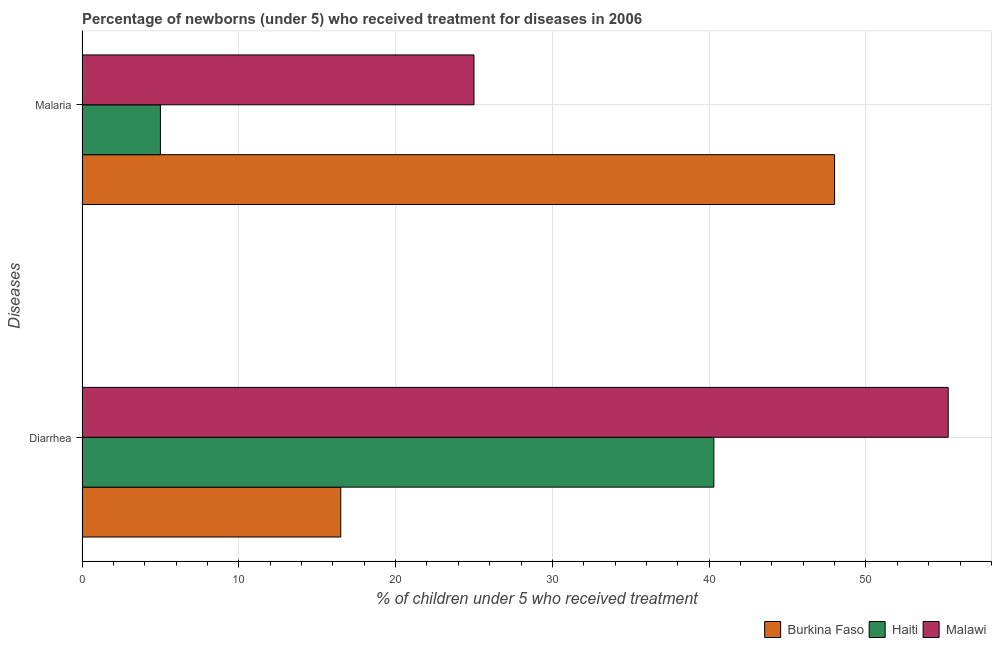How many different coloured bars are there?
Offer a very short reply. 3. How many groups of bars are there?
Your answer should be very brief. 2. Are the number of bars per tick equal to the number of legend labels?
Your answer should be very brief. Yes. Are the number of bars on each tick of the Y-axis equal?
Provide a short and direct response. Yes. How many bars are there on the 1st tick from the top?
Offer a very short reply. 3. How many bars are there on the 2nd tick from the bottom?
Provide a succinct answer. 3. What is the label of the 1st group of bars from the top?
Make the answer very short. Malaria. What is the percentage of children who received treatment for diarrhoea in Burkina Faso?
Make the answer very short. 16.5. Across all countries, what is the maximum percentage of children who received treatment for malaria?
Give a very brief answer. 48. Across all countries, what is the minimum percentage of children who received treatment for diarrhoea?
Your response must be concise. 16.5. In which country was the percentage of children who received treatment for malaria maximum?
Provide a short and direct response. Burkina Faso. In which country was the percentage of children who received treatment for malaria minimum?
Ensure brevity in your answer.  Haiti. What is the total percentage of children who received treatment for diarrhoea in the graph?
Your answer should be very brief. 112.05. What is the difference between the percentage of children who received treatment for diarrhoea in Haiti and the percentage of children who received treatment for malaria in Malawi?
Ensure brevity in your answer.  15.3. What is the average percentage of children who received treatment for diarrhoea per country?
Keep it short and to the point. 37.35. What is the difference between the percentage of children who received treatment for diarrhoea and percentage of children who received treatment for malaria in Malawi?
Keep it short and to the point. 30.25. What does the 1st bar from the top in Diarrhea represents?
Ensure brevity in your answer.  Malawi. What does the 3rd bar from the bottom in Diarrhea represents?
Keep it short and to the point. Malawi. What is the difference between two consecutive major ticks on the X-axis?
Your response must be concise. 10. Are the values on the major ticks of X-axis written in scientific E-notation?
Your response must be concise. No. Does the graph contain any zero values?
Your answer should be compact. No. Does the graph contain grids?
Keep it short and to the point. Yes. Where does the legend appear in the graph?
Give a very brief answer. Bottom right. How many legend labels are there?
Your response must be concise. 3. How are the legend labels stacked?
Make the answer very short. Horizontal. What is the title of the graph?
Keep it short and to the point. Percentage of newborns (under 5) who received treatment for diseases in 2006. Does "Grenada" appear as one of the legend labels in the graph?
Provide a succinct answer. No. What is the label or title of the X-axis?
Provide a succinct answer. % of children under 5 who received treatment. What is the label or title of the Y-axis?
Make the answer very short. Diseases. What is the % of children under 5 who received treatment of Burkina Faso in Diarrhea?
Provide a short and direct response. 16.5. What is the % of children under 5 who received treatment of Haiti in Diarrhea?
Make the answer very short. 40.3. What is the % of children under 5 who received treatment of Malawi in Diarrhea?
Provide a succinct answer. 55.25. What is the % of children under 5 who received treatment in Malawi in Malaria?
Keep it short and to the point. 25. Across all Diseases, what is the maximum % of children under 5 who received treatment of Haiti?
Offer a terse response. 40.3. Across all Diseases, what is the maximum % of children under 5 who received treatment in Malawi?
Give a very brief answer. 55.25. Across all Diseases, what is the minimum % of children under 5 who received treatment of Burkina Faso?
Your response must be concise. 16.5. What is the total % of children under 5 who received treatment of Burkina Faso in the graph?
Ensure brevity in your answer.  64.5. What is the total % of children under 5 who received treatment in Haiti in the graph?
Give a very brief answer. 45.3. What is the total % of children under 5 who received treatment of Malawi in the graph?
Give a very brief answer. 80.25. What is the difference between the % of children under 5 who received treatment in Burkina Faso in Diarrhea and that in Malaria?
Ensure brevity in your answer.  -31.5. What is the difference between the % of children under 5 who received treatment in Haiti in Diarrhea and that in Malaria?
Offer a terse response. 35.3. What is the difference between the % of children under 5 who received treatment of Malawi in Diarrhea and that in Malaria?
Make the answer very short. 30.25. What is the difference between the % of children under 5 who received treatment of Burkina Faso in Diarrhea and the % of children under 5 who received treatment of Haiti in Malaria?
Keep it short and to the point. 11.5. What is the difference between the % of children under 5 who received treatment of Burkina Faso in Diarrhea and the % of children under 5 who received treatment of Malawi in Malaria?
Provide a short and direct response. -8.5. What is the average % of children under 5 who received treatment in Burkina Faso per Diseases?
Offer a terse response. 32.25. What is the average % of children under 5 who received treatment of Haiti per Diseases?
Your answer should be compact. 22.65. What is the average % of children under 5 who received treatment of Malawi per Diseases?
Offer a terse response. 40.12. What is the difference between the % of children under 5 who received treatment of Burkina Faso and % of children under 5 who received treatment of Haiti in Diarrhea?
Your response must be concise. -23.8. What is the difference between the % of children under 5 who received treatment in Burkina Faso and % of children under 5 who received treatment in Malawi in Diarrhea?
Your answer should be compact. -38.74. What is the difference between the % of children under 5 who received treatment of Haiti and % of children under 5 who received treatment of Malawi in Diarrhea?
Your response must be concise. -14.95. What is the ratio of the % of children under 5 who received treatment in Burkina Faso in Diarrhea to that in Malaria?
Your answer should be compact. 0.34. What is the ratio of the % of children under 5 who received treatment of Haiti in Diarrhea to that in Malaria?
Make the answer very short. 8.06. What is the ratio of the % of children under 5 who received treatment in Malawi in Diarrhea to that in Malaria?
Your answer should be compact. 2.21. What is the difference between the highest and the second highest % of children under 5 who received treatment of Burkina Faso?
Your response must be concise. 31.5. What is the difference between the highest and the second highest % of children under 5 who received treatment in Haiti?
Provide a succinct answer. 35.3. What is the difference between the highest and the second highest % of children under 5 who received treatment of Malawi?
Provide a short and direct response. 30.25. What is the difference between the highest and the lowest % of children under 5 who received treatment in Burkina Faso?
Your answer should be very brief. 31.5. What is the difference between the highest and the lowest % of children under 5 who received treatment in Haiti?
Ensure brevity in your answer.  35.3. What is the difference between the highest and the lowest % of children under 5 who received treatment in Malawi?
Provide a succinct answer. 30.25. 